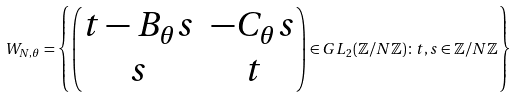<formula> <loc_0><loc_0><loc_500><loc_500>W _ { N , \theta } = \left \{ \begin{pmatrix} t - B _ { \theta } s & - C _ { \theta } s \\ s & t \end{pmatrix} \in G L _ { 2 } ( \mathbb { Z } / N \mathbb { Z } ) \colon t , s \in \mathbb { Z } / N \mathbb { Z } \right \}</formula> 